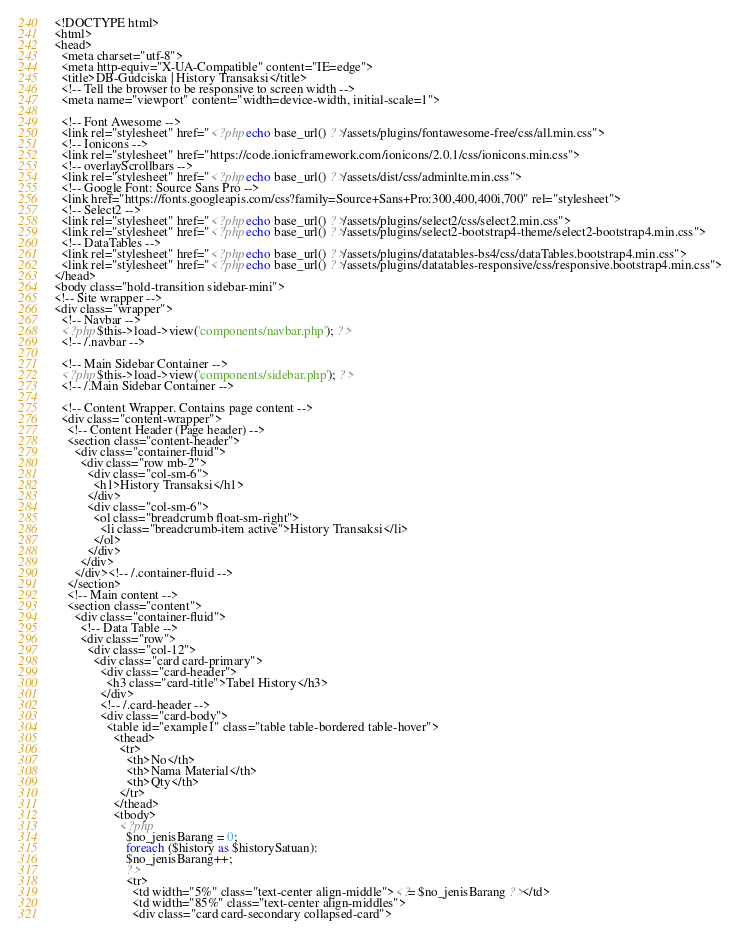Convert code to text. <code><loc_0><loc_0><loc_500><loc_500><_PHP_><!DOCTYPE html>
<html>
<head>
  <meta charset="utf-8">
  <meta http-equiv="X-UA-Compatible" content="IE=edge">
  <title>DB-Gudciska | History Transaksi</title>
  <!-- Tell the browser to be responsive to screen width -->
  <meta name="viewport" content="width=device-width, initial-scale=1">

  <!-- Font Awesome -->
  <link rel="stylesheet" href="<?php echo base_url() ?>/assets/plugins/fontawesome-free/css/all.min.css">
  <!-- Ionicons -->
  <link rel="stylesheet" href="https://code.ionicframework.com/ionicons/2.0.1/css/ionicons.min.css">
  <!-- overlayScrollbars -->
  <link rel="stylesheet" href="<?php echo base_url() ?>/assets/dist/css/adminlte.min.css">
  <!-- Google Font: Source Sans Pro -->
  <link href="https://fonts.googleapis.com/css?family=Source+Sans+Pro:300,400,400i,700" rel="stylesheet">
  <!-- Select2 -->
  <link rel="stylesheet" href="<?php echo base_url() ?>/assets/plugins/select2/css/select2.min.css">
  <link rel="stylesheet" href="<?php echo base_url() ?>/assets/plugins/select2-bootstrap4-theme/select2-bootstrap4.min.css">
  <!-- DataTables -->
  <link rel="stylesheet" href="<?php echo base_url() ?>/assets/plugins/datatables-bs4/css/dataTables.bootstrap4.min.css">
  <link rel="stylesheet" href="<?php echo base_url() ?>/assets/plugins/datatables-responsive/css/responsive.bootstrap4.min.css">
</head>
<body class="hold-transition sidebar-mini">
<!-- Site wrapper -->
<div class="wrapper">
  <!-- Navbar -->
  <?php $this->load->view('components/navbar.php'); ?>
  <!-- /.navbar -->

  <!-- Main Sidebar Container -->
  <?php $this->load->view('components/sidebar.php'); ?>
  <!-- /.Main Sidebar Container -->

  <!-- Content Wrapper. Contains page content -->
  <div class="content-wrapper">
    <!-- Content Header (Page header) -->
    <section class="content-header">
      <div class="container-fluid">
        <div class="row mb-2">
          <div class="col-sm-6">
            <h1>History Transaksi</h1>
          </div>
          <div class="col-sm-6">
            <ol class="breadcrumb float-sm-right">
              <li class="breadcrumb-item active">History Transaksi</li>
            </ol>
          </div>
        </div>
      </div><!-- /.container-fluid -->
    </section>
    <!-- Main content -->
    <section class="content">
      <div class="container-fluid">
        <!-- Data Table -->
        <div class="row">
          <div class="col-12">
            <div class="card card-primary">
              <div class="card-header">
                <h3 class="card-title">Tabel History</h3>
              </div>
              <!-- /.card-header -->
              <div class="card-body">
                <table id="example1" class="table table-bordered table-hover">
                  <thead>
                    <tr>
                      <th>No</th>
                      <th>Nama Material</th>
                      <th>Qty</th>
                    </tr>
                  </thead>
                  <tbody>
                    <?php
                      $no_jenisBarang = 0;
                      foreach ($history as $historySatuan):
                      $no_jenisBarang++;
                      ?>
                      <tr>
                        <td width="5%" class="text-center align-middle"><?= $no_jenisBarang ?></td>
                        <td width="85%" class="text-center align-middles">
                        <div class="card card-secondary collapsed-card"></code> 